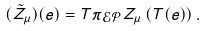Convert formula to latex. <formula><loc_0><loc_0><loc_500><loc_500>( \tilde { Z } _ { \mu } ) { ( e ) } = T \pi _ { \mathcal { E } \mathcal { P } } Z _ { \mu } \left ( { T ( e ) } \right ) .</formula> 